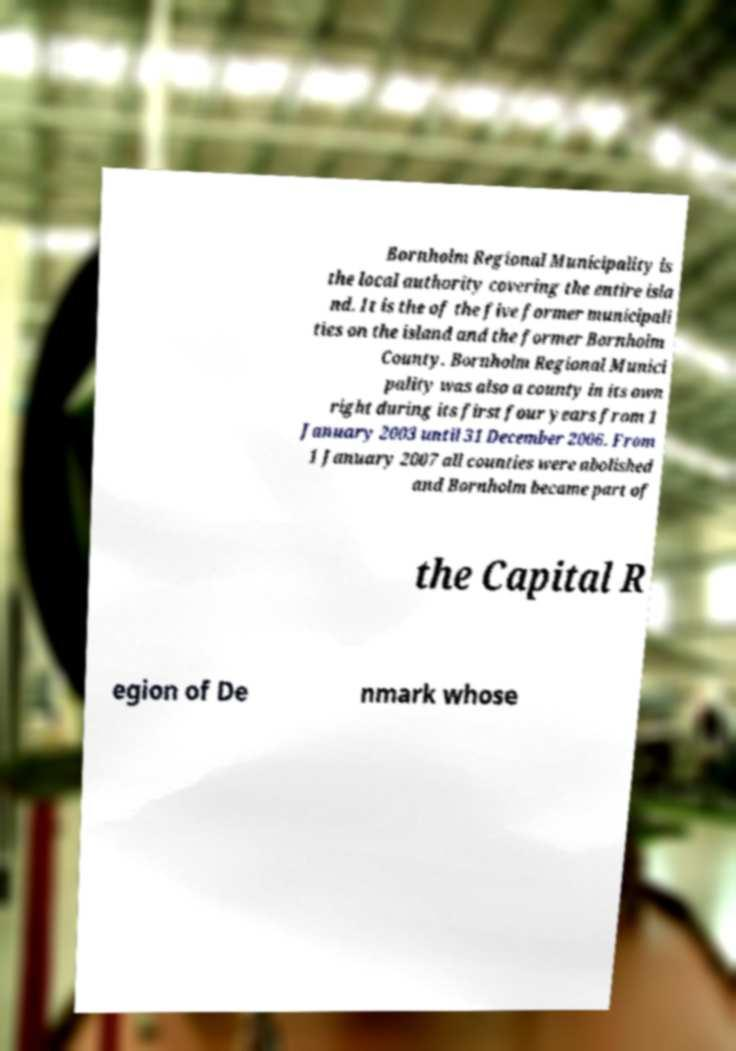For documentation purposes, I need the text within this image transcribed. Could you provide that? Bornholm Regional Municipality is the local authority covering the entire isla nd. It is the of the five former municipali ties on the island and the former Bornholm County. Bornholm Regional Munici pality was also a county in its own right during its first four years from 1 January 2003 until 31 December 2006. From 1 January 2007 all counties were abolished and Bornholm became part of the Capital R egion of De nmark whose 